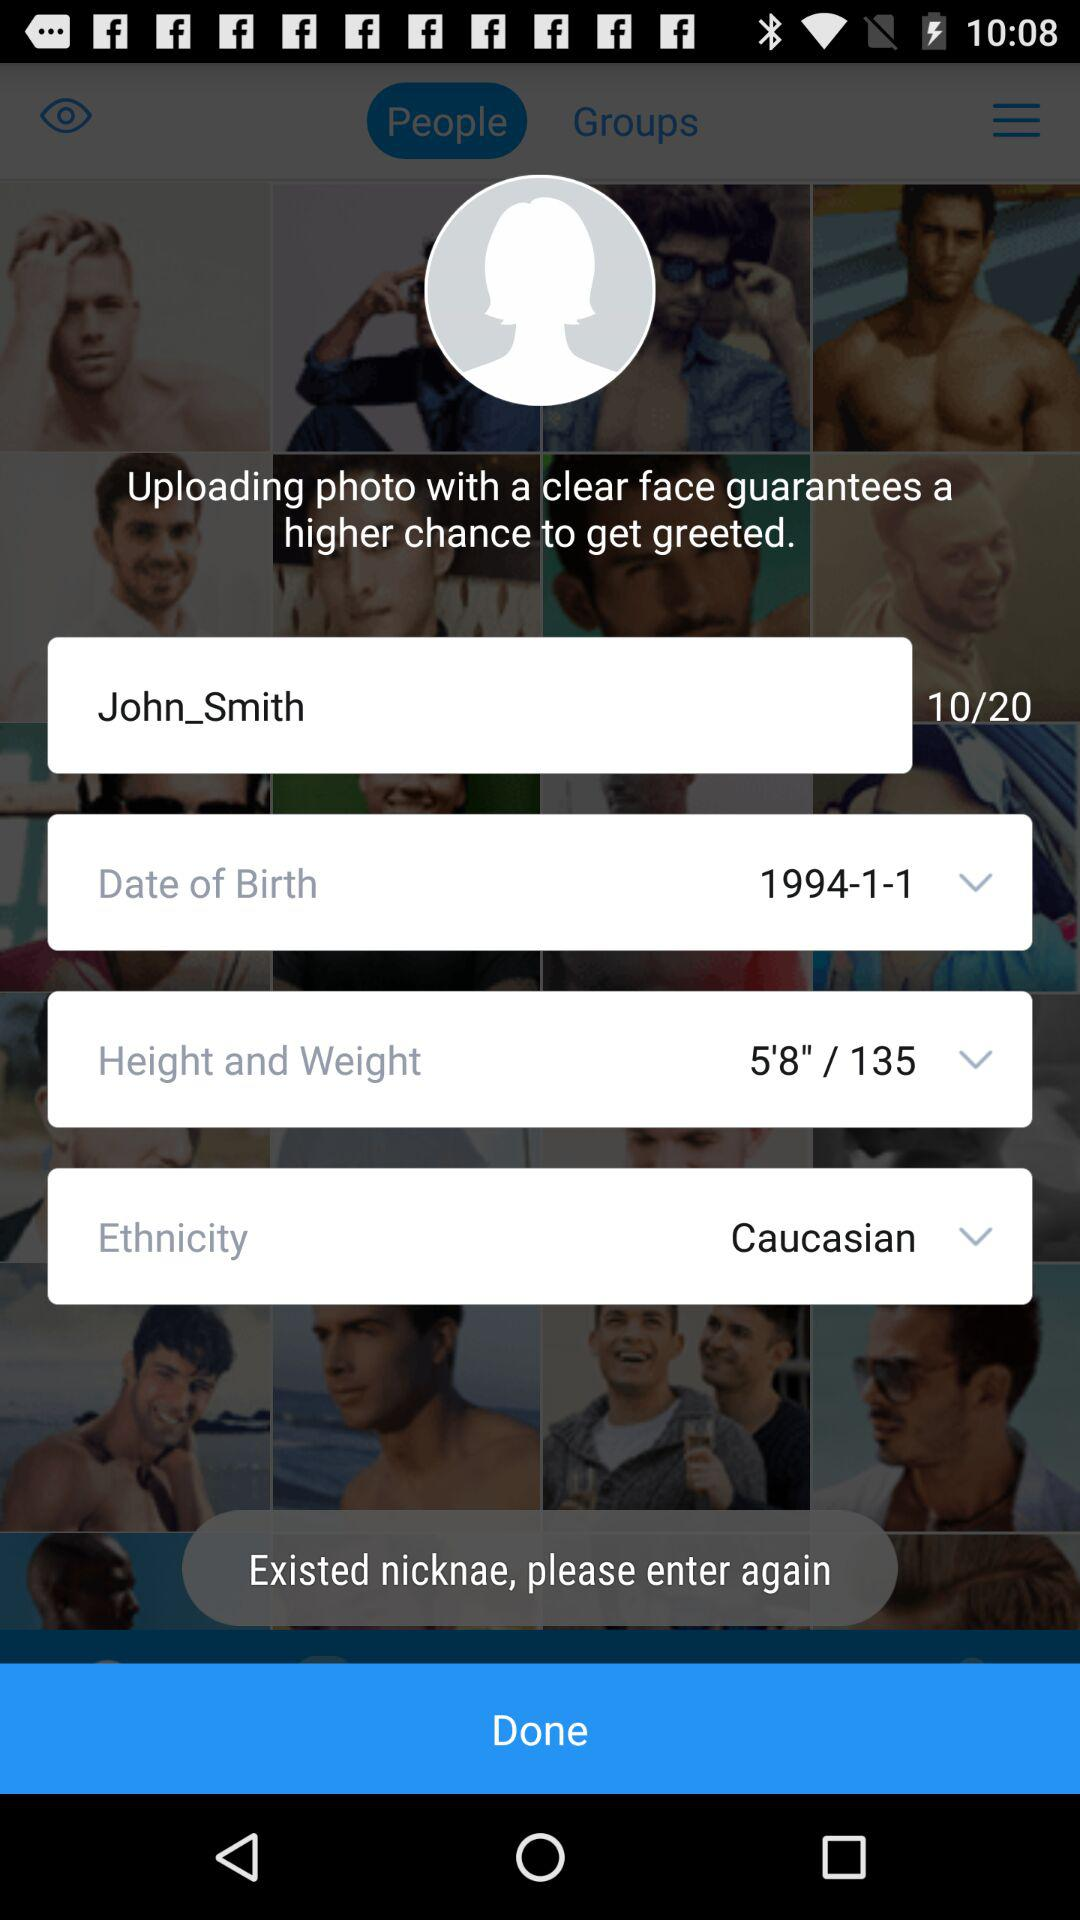What is the application name? The application name is "blued". 